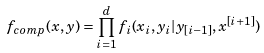Convert formula to latex. <formula><loc_0><loc_0><loc_500><loc_500>f _ { c o m p } ( x , y ) = \prod _ { i = 1 } ^ { d } f _ { i } ( x _ { i } , y _ { i } | y _ { [ i - 1 ] } , x ^ { [ i + 1 ] } )</formula> 